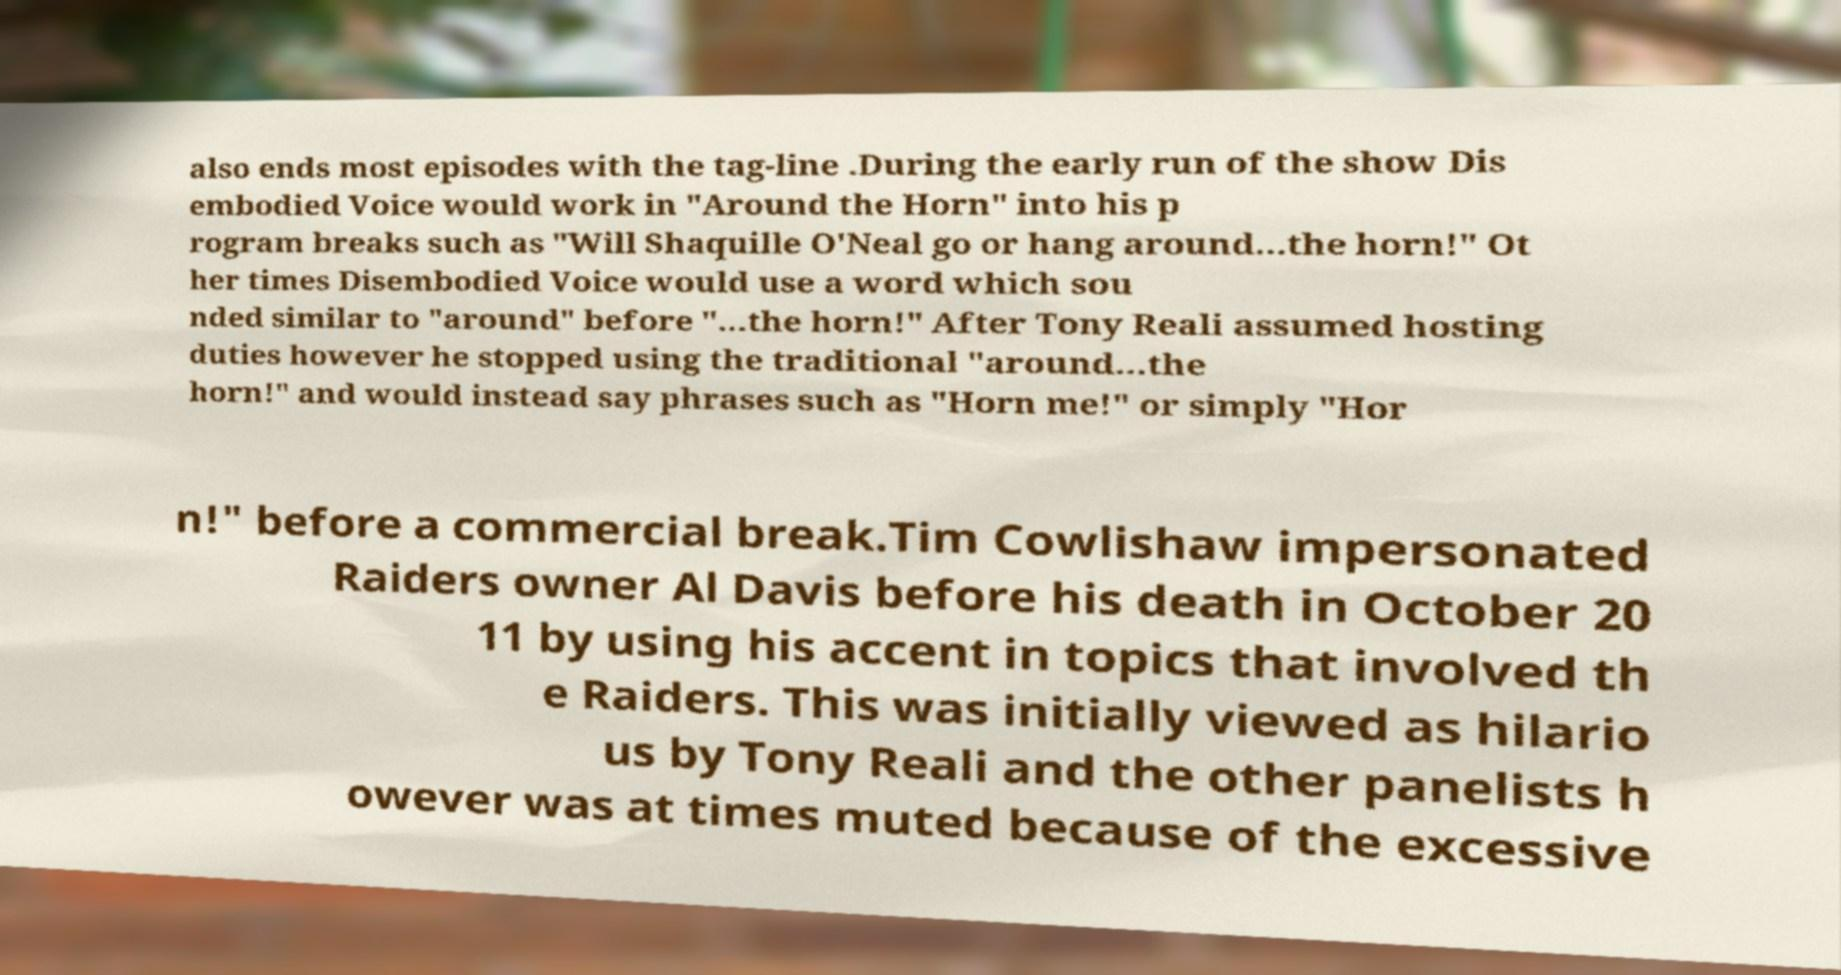For documentation purposes, I need the text within this image transcribed. Could you provide that? also ends most episodes with the tag-line .During the early run of the show Dis embodied Voice would work in "Around the Horn" into his p rogram breaks such as "Will Shaquille O'Neal go or hang around...the horn!" Ot her times Disembodied Voice would use a word which sou nded similar to "around" before "...the horn!" After Tony Reali assumed hosting duties however he stopped using the traditional "around...the horn!" and would instead say phrases such as "Horn me!" or simply "Hor n!" before a commercial break.Tim Cowlishaw impersonated Raiders owner Al Davis before his death in October 20 11 by using his accent in topics that involved th e Raiders. This was initially viewed as hilario us by Tony Reali and the other panelists h owever was at times muted because of the excessive 